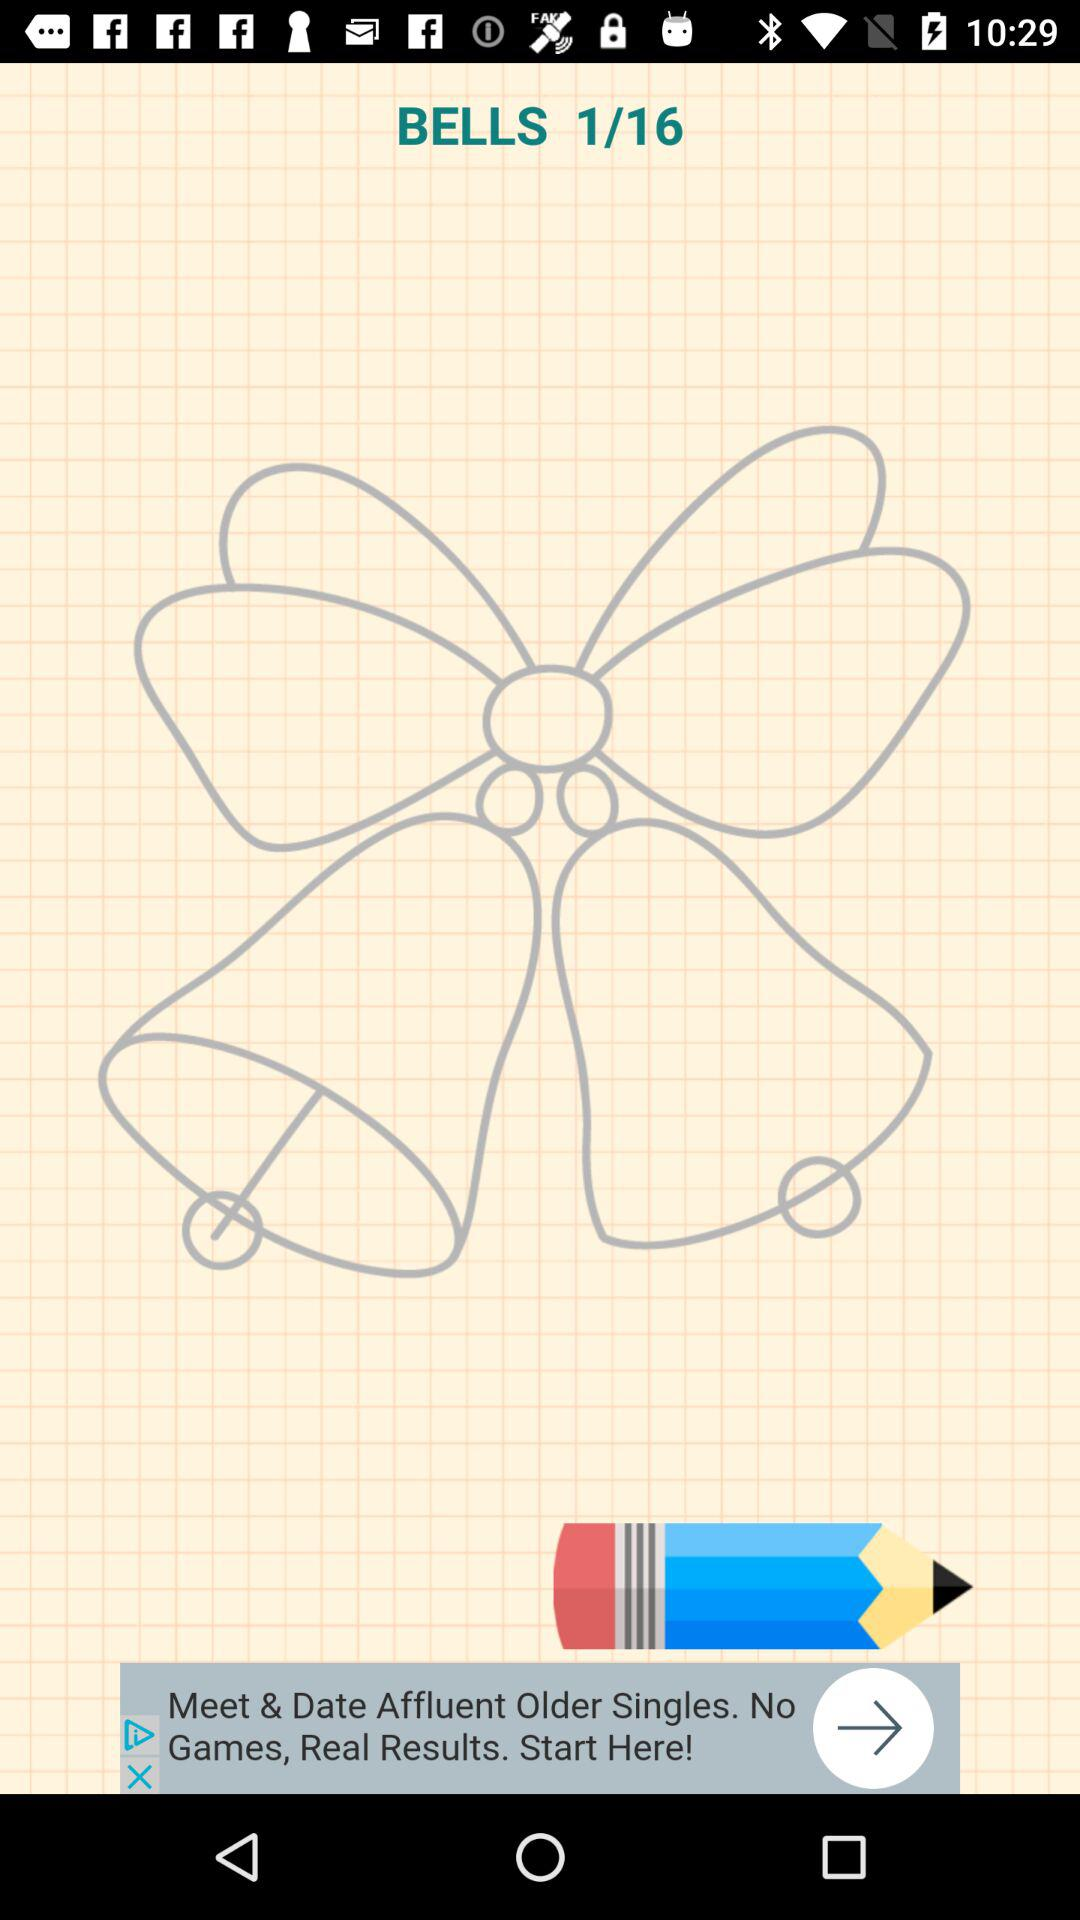What is the current image number? The current image number is 1. 